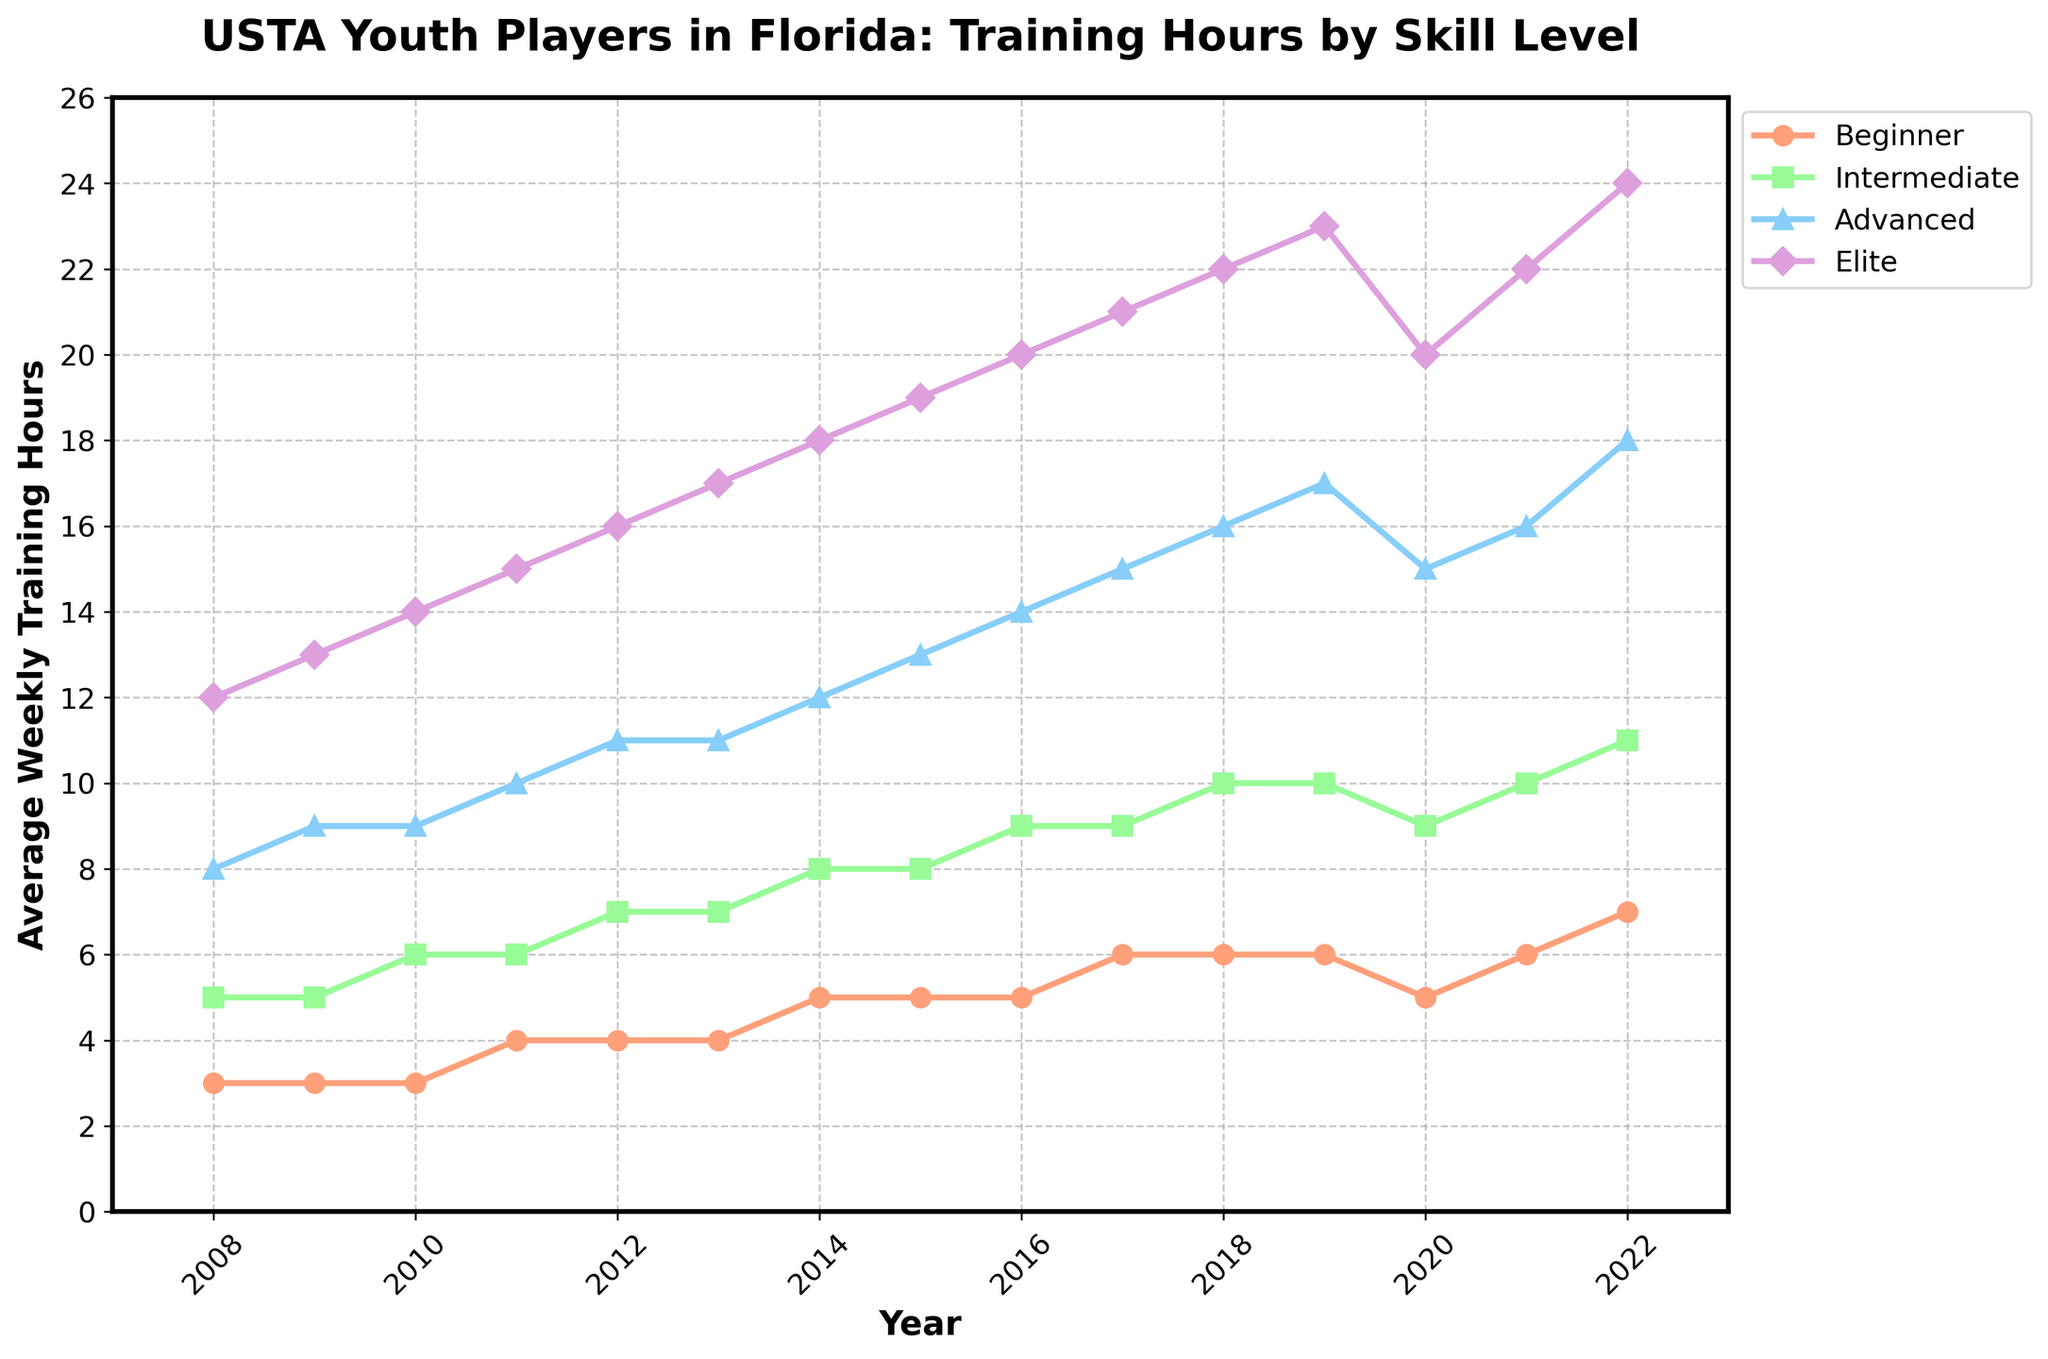What is the average weekly training hours for Elite players in 2016 and 2018? Add the weekly training hours for Elite players in 2016 and 2018, then divide by 2: (20 + 22) / 2 = 21
Answer: 21 Which group showed the biggest increase in average weekly training hours from 2008 to 2022? Calculate the difference in training hours for each group between 2008 and 2022: Beginner (7 - 3 = 4), Intermediate (11 - 5 = 6), Advanced (18 - 8 = 10), Elite (24 - 12 = 12). The Elite group has the biggest increase.
Answer: Elite In which year did Intermediate players start training an average of 10 hours per week? Look at the data for Intermediate players and find the first year when the average training hours hit 10: It occurs in 2018.
Answer: 2018 How did the average weekly training hours for Advanced players change between 2019 and 2020? Subtract the 2020 value from the 2019 value for Advanced players: 17 - 15 = 2. Advanced players’ average training hours decreased by 2 hours.
Answer: Decreased by 2 Between 2012 and 2022, which skill level saw the least change in average weekly training hours? Calculate the change for each group from 2012 to 2022: Beginner (7-4 = 3), Intermediate (11-7 = 4), Advanced (18-11 = 7), Elite (24-16 = 8). The Beginner group saw the least change.
Answer: Beginner In 2020, how many more hours did Elite players train compared to Beginner players? Subtract the 2020 value for Beginner players from the Elite players: 20 - 5 = 15. Elite players trained 15 more hours than Beginner players.
Answer: 15 What is the trend in average weekly training hours for Beginner players from 2010 to 2016? Observing the data from 2010 to 2016 shows a gradual increase: 3 (2010), 4 (2011, 2012), 5 (2014, 2015), and 5 (2016). Beginner players' training hours are generally increasing.
Answer: Increasing Which year did Advanced players reach an average of 12 hours per week? Locate the year when Advanced players' training hours first reached 12: This happened in 2014.
Answer: 2014 In 2022, by how much did Elite players out-train Intermediate players in average weekly hours? Subtract the 2022 value for Intermediate players from the Elite players: 24 - 11 = 13. Elite players out-trained Intermediate players by 13 hours.
Answer: 13 